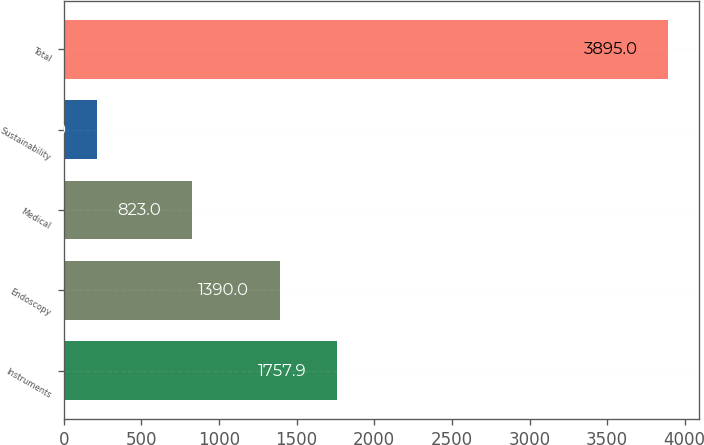Convert chart. <chart><loc_0><loc_0><loc_500><loc_500><bar_chart><fcel>Instruments<fcel>Endoscopy<fcel>Medical<fcel>Sustainability<fcel>Total<nl><fcel>1757.9<fcel>1390<fcel>823<fcel>216<fcel>3895<nl></chart> 